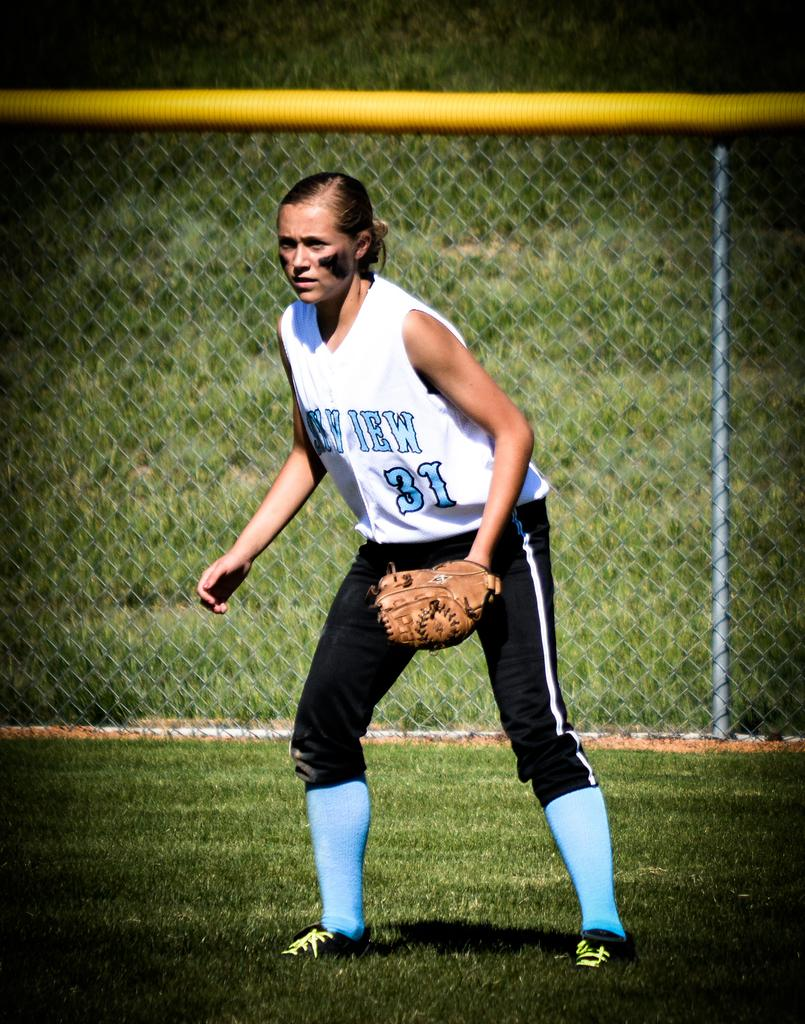<image>
Offer a succinct explanation of the picture presented. A baseball player with the team number 31 is positioned in the outfield. 